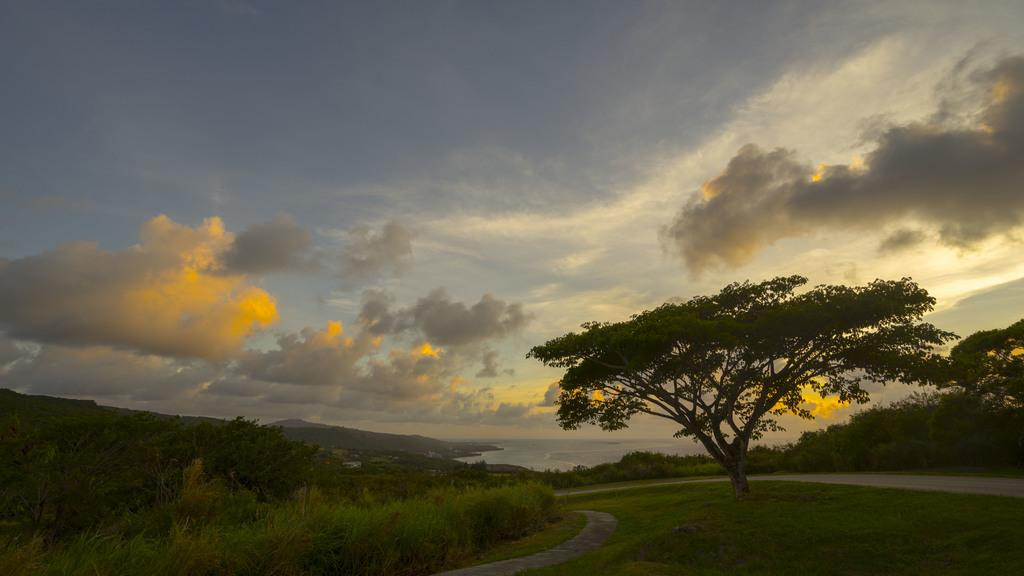What type of natural elements can be seen in the image? There are trees in the image. What man-made structure is visible on the right side of the image? There is a road on the right side of the image. What part of the natural environment is visible in the image? The sky is visible at the top of the image. How is the sky described in the image? The sky is described as beautiful in the image. What type of substance is being consumed by the trees in the image? There is no substance being consumed by the trees in the image; they are stationary and not shown to be consuming anything. 